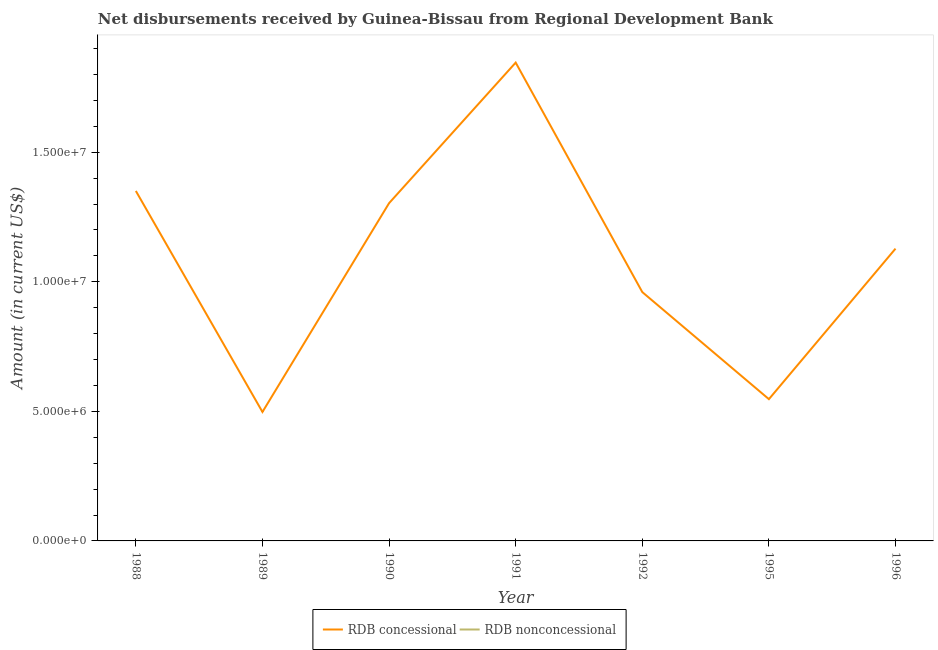How many different coloured lines are there?
Offer a terse response. 1. Does the line corresponding to net non concessional disbursements from rdb intersect with the line corresponding to net concessional disbursements from rdb?
Your answer should be very brief. No. Is the number of lines equal to the number of legend labels?
Make the answer very short. No. What is the net non concessional disbursements from rdb in 1996?
Give a very brief answer. 0. Across all years, what is the maximum net concessional disbursements from rdb?
Your answer should be compact. 1.85e+07. Across all years, what is the minimum net concessional disbursements from rdb?
Offer a terse response. 4.98e+06. In which year was the net concessional disbursements from rdb maximum?
Provide a short and direct response. 1991. What is the difference between the net concessional disbursements from rdb in 1991 and that in 1995?
Provide a succinct answer. 1.30e+07. What is the difference between the net non concessional disbursements from rdb in 1991 and the net concessional disbursements from rdb in 1988?
Make the answer very short. -1.35e+07. What is the average net non concessional disbursements from rdb per year?
Your response must be concise. 0. What is the ratio of the net concessional disbursements from rdb in 1990 to that in 1991?
Offer a terse response. 0.71. Is the net concessional disbursements from rdb in 1988 less than that in 1991?
Offer a very short reply. Yes. What is the difference between the highest and the second highest net concessional disbursements from rdb?
Keep it short and to the point. 4.95e+06. What is the difference between the highest and the lowest net concessional disbursements from rdb?
Offer a terse response. 1.35e+07. Does the net non concessional disbursements from rdb monotonically increase over the years?
Ensure brevity in your answer.  No. Is the net non concessional disbursements from rdb strictly less than the net concessional disbursements from rdb over the years?
Make the answer very short. Yes. What is the difference between two consecutive major ticks on the Y-axis?
Make the answer very short. 5.00e+06. Are the values on the major ticks of Y-axis written in scientific E-notation?
Offer a terse response. Yes. Does the graph contain any zero values?
Ensure brevity in your answer.  Yes. How many legend labels are there?
Keep it short and to the point. 2. What is the title of the graph?
Provide a short and direct response. Net disbursements received by Guinea-Bissau from Regional Development Bank. Does "Female labourers" appear as one of the legend labels in the graph?
Provide a succinct answer. No. What is the Amount (in current US$) in RDB concessional in 1988?
Offer a terse response. 1.35e+07. What is the Amount (in current US$) in RDB concessional in 1989?
Make the answer very short. 4.98e+06. What is the Amount (in current US$) of RDB concessional in 1990?
Offer a very short reply. 1.30e+07. What is the Amount (in current US$) in RDB concessional in 1991?
Offer a terse response. 1.85e+07. What is the Amount (in current US$) of RDB nonconcessional in 1991?
Give a very brief answer. 0. What is the Amount (in current US$) of RDB concessional in 1992?
Make the answer very short. 9.60e+06. What is the Amount (in current US$) in RDB nonconcessional in 1992?
Offer a very short reply. 0. What is the Amount (in current US$) in RDB concessional in 1995?
Your response must be concise. 5.47e+06. What is the Amount (in current US$) of RDB concessional in 1996?
Ensure brevity in your answer.  1.13e+07. What is the Amount (in current US$) in RDB nonconcessional in 1996?
Your answer should be very brief. 0. Across all years, what is the maximum Amount (in current US$) of RDB concessional?
Offer a very short reply. 1.85e+07. Across all years, what is the minimum Amount (in current US$) in RDB concessional?
Your response must be concise. 4.98e+06. What is the total Amount (in current US$) of RDB concessional in the graph?
Make the answer very short. 7.63e+07. What is the total Amount (in current US$) in RDB nonconcessional in the graph?
Provide a succinct answer. 0. What is the difference between the Amount (in current US$) in RDB concessional in 1988 and that in 1989?
Provide a short and direct response. 8.53e+06. What is the difference between the Amount (in current US$) in RDB concessional in 1988 and that in 1990?
Give a very brief answer. 4.71e+05. What is the difference between the Amount (in current US$) in RDB concessional in 1988 and that in 1991?
Your answer should be very brief. -4.95e+06. What is the difference between the Amount (in current US$) in RDB concessional in 1988 and that in 1992?
Your answer should be compact. 3.90e+06. What is the difference between the Amount (in current US$) in RDB concessional in 1988 and that in 1995?
Make the answer very short. 8.04e+06. What is the difference between the Amount (in current US$) in RDB concessional in 1988 and that in 1996?
Ensure brevity in your answer.  2.23e+06. What is the difference between the Amount (in current US$) in RDB concessional in 1989 and that in 1990?
Offer a terse response. -8.06e+06. What is the difference between the Amount (in current US$) of RDB concessional in 1989 and that in 1991?
Your answer should be compact. -1.35e+07. What is the difference between the Amount (in current US$) in RDB concessional in 1989 and that in 1992?
Provide a succinct answer. -4.63e+06. What is the difference between the Amount (in current US$) in RDB concessional in 1989 and that in 1995?
Make the answer very short. -4.94e+05. What is the difference between the Amount (in current US$) in RDB concessional in 1989 and that in 1996?
Your answer should be very brief. -6.30e+06. What is the difference between the Amount (in current US$) in RDB concessional in 1990 and that in 1991?
Keep it short and to the point. -5.42e+06. What is the difference between the Amount (in current US$) in RDB concessional in 1990 and that in 1992?
Your response must be concise. 3.43e+06. What is the difference between the Amount (in current US$) of RDB concessional in 1990 and that in 1995?
Your response must be concise. 7.56e+06. What is the difference between the Amount (in current US$) in RDB concessional in 1990 and that in 1996?
Offer a very short reply. 1.76e+06. What is the difference between the Amount (in current US$) in RDB concessional in 1991 and that in 1992?
Keep it short and to the point. 8.86e+06. What is the difference between the Amount (in current US$) of RDB concessional in 1991 and that in 1995?
Your response must be concise. 1.30e+07. What is the difference between the Amount (in current US$) in RDB concessional in 1991 and that in 1996?
Offer a very short reply. 7.18e+06. What is the difference between the Amount (in current US$) of RDB concessional in 1992 and that in 1995?
Ensure brevity in your answer.  4.13e+06. What is the difference between the Amount (in current US$) in RDB concessional in 1992 and that in 1996?
Your answer should be compact. -1.68e+06. What is the difference between the Amount (in current US$) in RDB concessional in 1995 and that in 1996?
Give a very brief answer. -5.81e+06. What is the average Amount (in current US$) of RDB concessional per year?
Your response must be concise. 1.09e+07. What is the average Amount (in current US$) in RDB nonconcessional per year?
Offer a terse response. 0. What is the ratio of the Amount (in current US$) in RDB concessional in 1988 to that in 1989?
Your response must be concise. 2.71. What is the ratio of the Amount (in current US$) of RDB concessional in 1988 to that in 1990?
Provide a succinct answer. 1.04. What is the ratio of the Amount (in current US$) of RDB concessional in 1988 to that in 1991?
Keep it short and to the point. 0.73. What is the ratio of the Amount (in current US$) of RDB concessional in 1988 to that in 1992?
Provide a short and direct response. 1.41. What is the ratio of the Amount (in current US$) of RDB concessional in 1988 to that in 1995?
Keep it short and to the point. 2.47. What is the ratio of the Amount (in current US$) of RDB concessional in 1988 to that in 1996?
Make the answer very short. 1.2. What is the ratio of the Amount (in current US$) in RDB concessional in 1989 to that in 1990?
Your response must be concise. 0.38. What is the ratio of the Amount (in current US$) of RDB concessional in 1989 to that in 1991?
Ensure brevity in your answer.  0.27. What is the ratio of the Amount (in current US$) of RDB concessional in 1989 to that in 1992?
Offer a very short reply. 0.52. What is the ratio of the Amount (in current US$) of RDB concessional in 1989 to that in 1995?
Keep it short and to the point. 0.91. What is the ratio of the Amount (in current US$) of RDB concessional in 1989 to that in 1996?
Your answer should be very brief. 0.44. What is the ratio of the Amount (in current US$) of RDB concessional in 1990 to that in 1991?
Keep it short and to the point. 0.71. What is the ratio of the Amount (in current US$) in RDB concessional in 1990 to that in 1992?
Provide a succinct answer. 1.36. What is the ratio of the Amount (in current US$) in RDB concessional in 1990 to that in 1995?
Keep it short and to the point. 2.38. What is the ratio of the Amount (in current US$) in RDB concessional in 1990 to that in 1996?
Your response must be concise. 1.16. What is the ratio of the Amount (in current US$) of RDB concessional in 1991 to that in 1992?
Your answer should be compact. 1.92. What is the ratio of the Amount (in current US$) of RDB concessional in 1991 to that in 1995?
Offer a very short reply. 3.37. What is the ratio of the Amount (in current US$) of RDB concessional in 1991 to that in 1996?
Offer a very short reply. 1.64. What is the ratio of the Amount (in current US$) of RDB concessional in 1992 to that in 1995?
Your answer should be compact. 1.76. What is the ratio of the Amount (in current US$) in RDB concessional in 1992 to that in 1996?
Offer a terse response. 0.85. What is the ratio of the Amount (in current US$) in RDB concessional in 1995 to that in 1996?
Your answer should be compact. 0.48. What is the difference between the highest and the second highest Amount (in current US$) of RDB concessional?
Provide a short and direct response. 4.95e+06. What is the difference between the highest and the lowest Amount (in current US$) in RDB concessional?
Ensure brevity in your answer.  1.35e+07. 